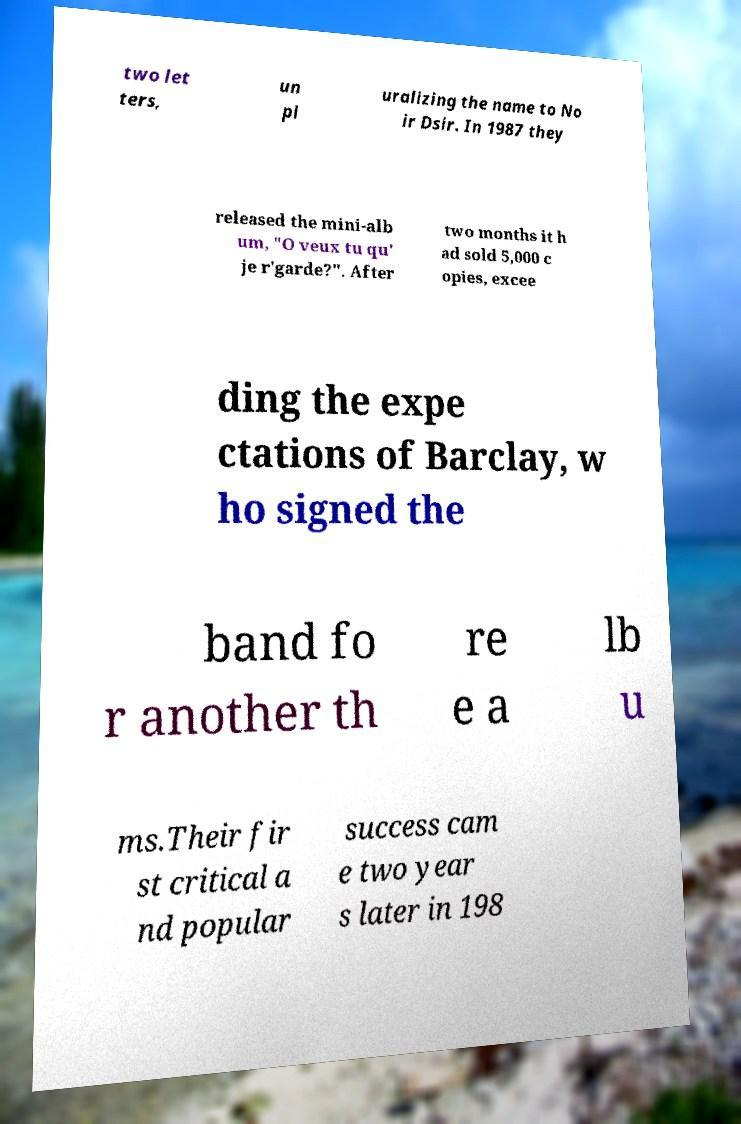Can you read and provide the text displayed in the image?This photo seems to have some interesting text. Can you extract and type it out for me? two let ters, un pl uralizing the name to No ir Dsir. In 1987 they released the mini-alb um, "O veux tu qu' je r'garde?". After two months it h ad sold 5,000 c opies, excee ding the expe ctations of Barclay, w ho signed the band fo r another th re e a lb u ms.Their fir st critical a nd popular success cam e two year s later in 198 